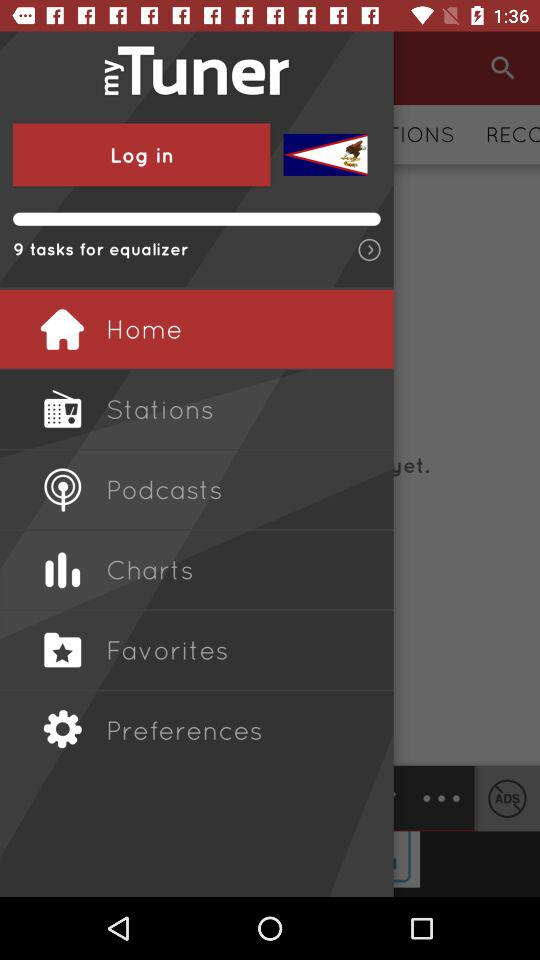Which item is selected in the menu? The selected item is "Home". 